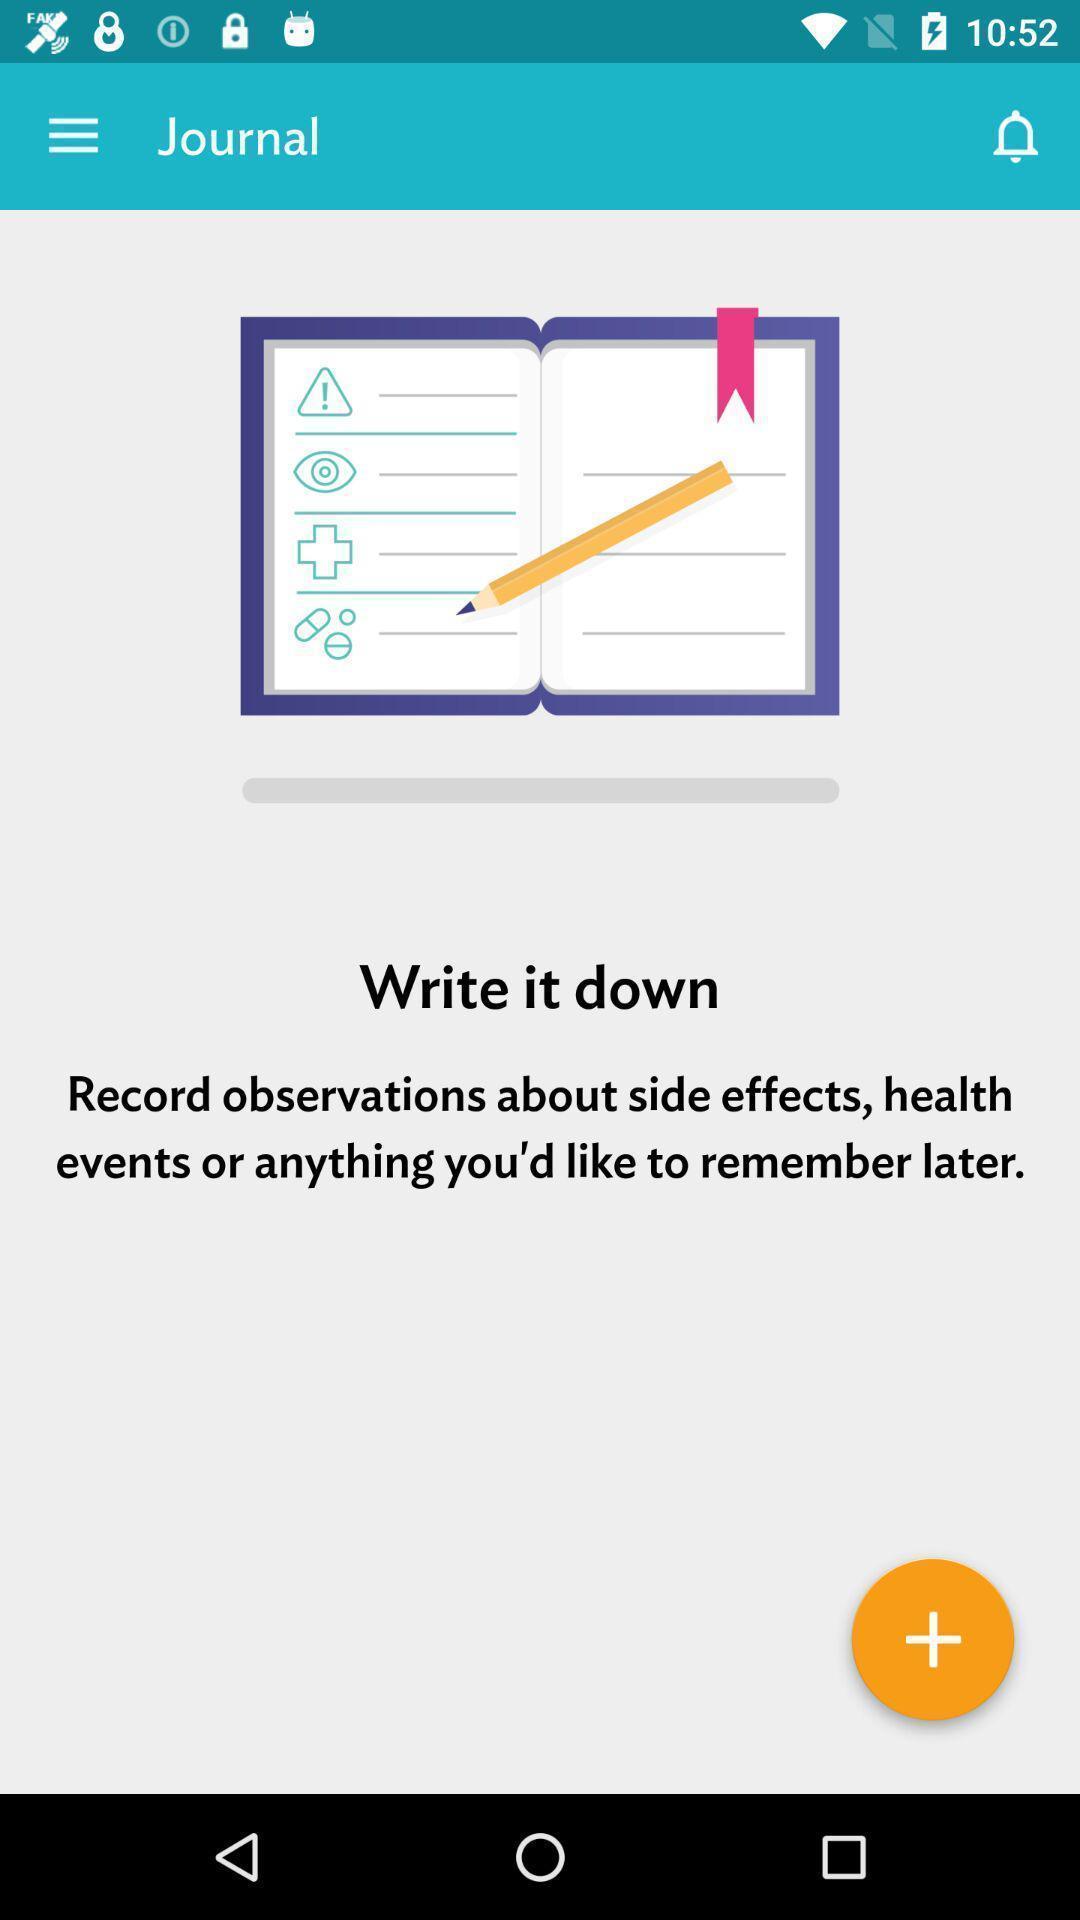Tell me about the visual elements in this screen capture. Screen displaying contents in journal page and a remainder icon. 